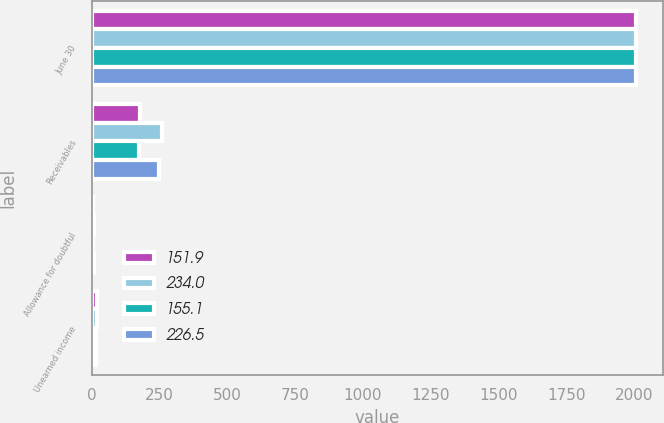Convert chart to OTSL. <chart><loc_0><loc_0><loc_500><loc_500><stacked_bar_chart><ecel><fcel>June 30<fcel>Receivables<fcel>Allowance for doubtful<fcel>Unearned income<nl><fcel>151.9<fcel>2008<fcel>177.7<fcel>4.5<fcel>18.1<nl><fcel>234<fcel>2008<fcel>259.7<fcel>7.9<fcel>17.8<nl><fcel>155.1<fcel>2007<fcel>173.6<fcel>4.8<fcel>16.9<nl><fcel>226.5<fcel>2007<fcel>249.7<fcel>8.3<fcel>14.9<nl></chart> 